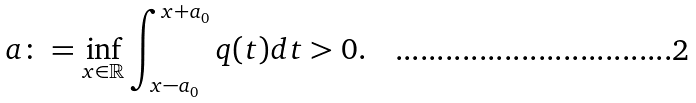<formula> <loc_0><loc_0><loc_500><loc_500>\ a \colon = \inf _ { x \in \mathbb { R } } \int _ { x - a _ { 0 } } ^ { x + a _ { 0 } } q ( t ) d t > 0 .</formula> 